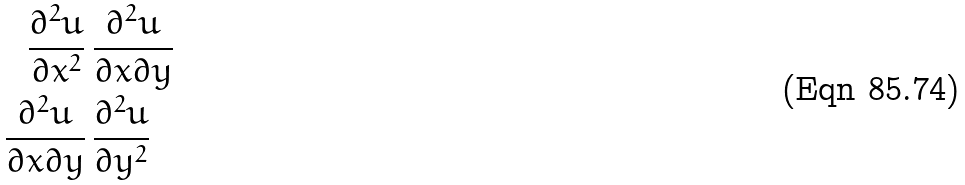<formula> <loc_0><loc_0><loc_500><loc_500>\frac { \partial ^ { 2 } u } { \partial x ^ { 2 } } \, & \frac { \partial ^ { 2 } u } { \partial x \partial y } \\ \frac { \partial ^ { 2 } u } { \partial x \partial y } \, & \frac { \partial ^ { 2 } u } { \partial y ^ { 2 } }</formula> 